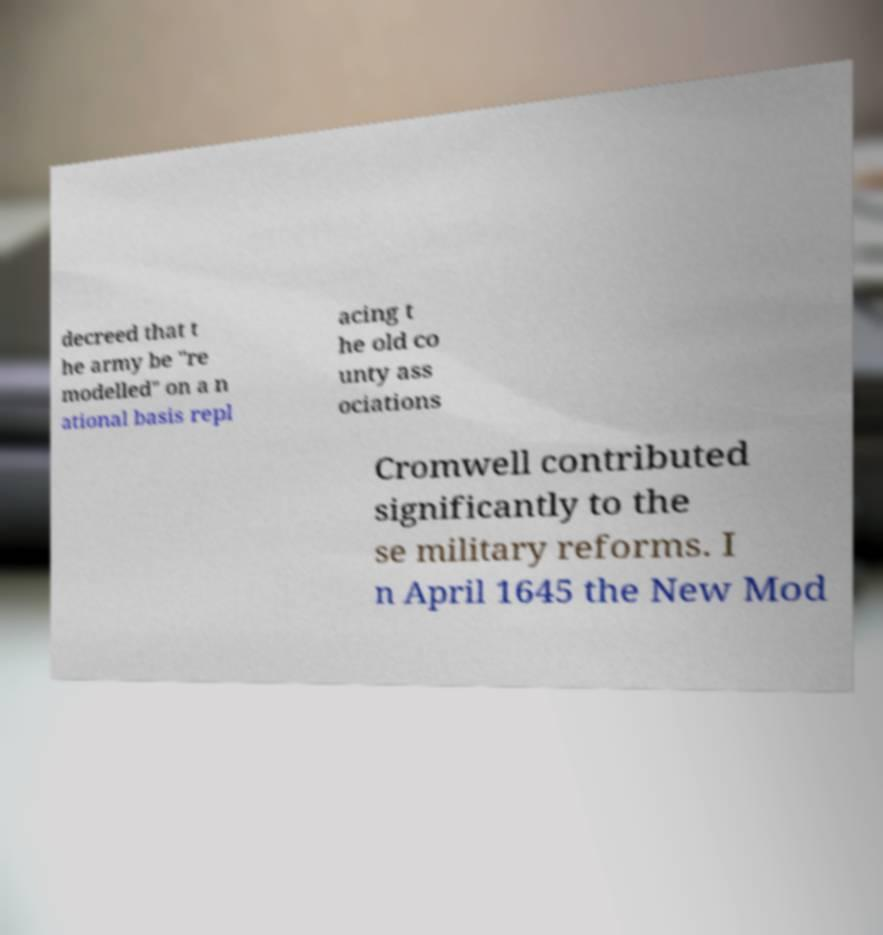Could you assist in decoding the text presented in this image and type it out clearly? decreed that t he army be "re modelled" on a n ational basis repl acing t he old co unty ass ociations Cromwell contributed significantly to the se military reforms. I n April 1645 the New Mod 